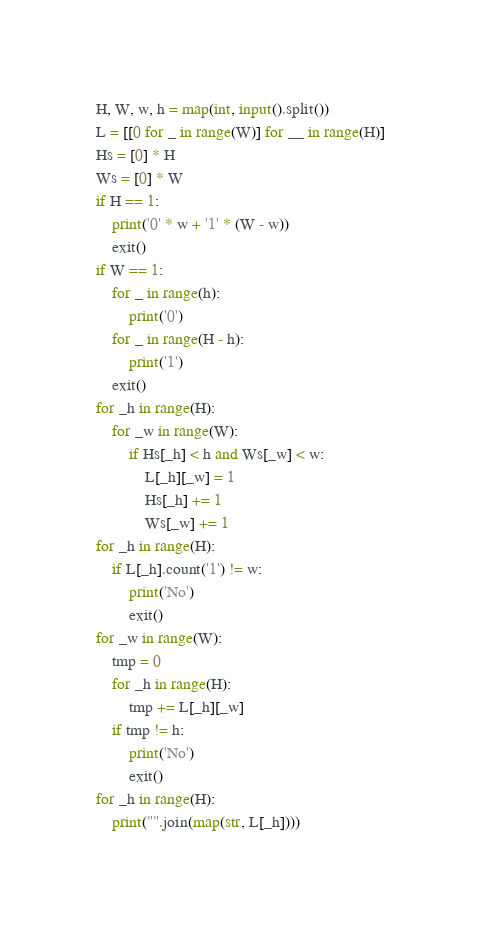<code> <loc_0><loc_0><loc_500><loc_500><_Python_>H, W, w, h = map(int, input().split())
L = [[0 for _ in range(W)] for __ in range(H)]
Hs = [0] * H
Ws = [0] * W
if H == 1:
    print('0' * w + '1' * (W - w))
    exit()
if W == 1:
    for _ in range(h):
        print('0')
    for _ in range(H - h):
        print('1')
    exit()
for _h in range(H):
    for _w in range(W):
        if Hs[_h] < h and Ws[_w] < w:
            L[_h][_w] = 1
            Hs[_h] += 1
            Ws[_w] += 1
for _h in range(H):
    if L[_h].count('1') != w:
        print('No')
        exit()
for _w in range(W):
    tmp = 0
    for _h in range(H):
        tmp += L[_h][_w]
    if tmp != h:
        print('No')
        exit()
for _h in range(H):
    print("".join(map(str, L[_h])))</code> 